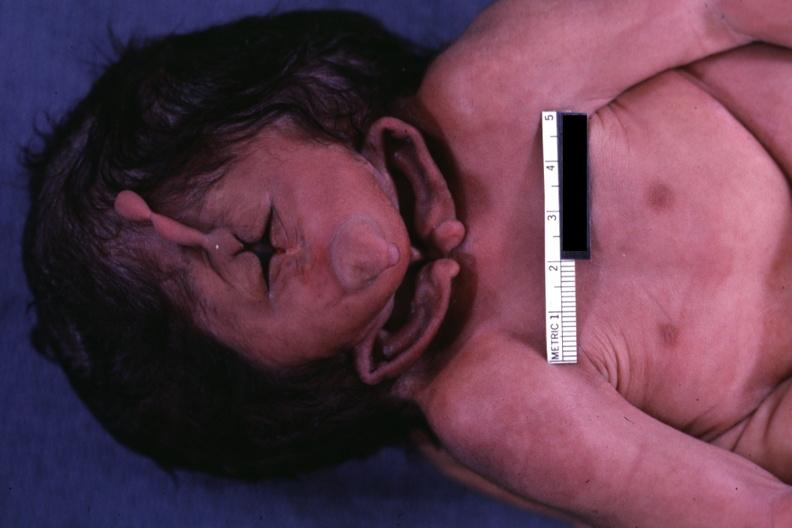s conjoined twins present?
Answer the question using a single word or phrase. Yes 